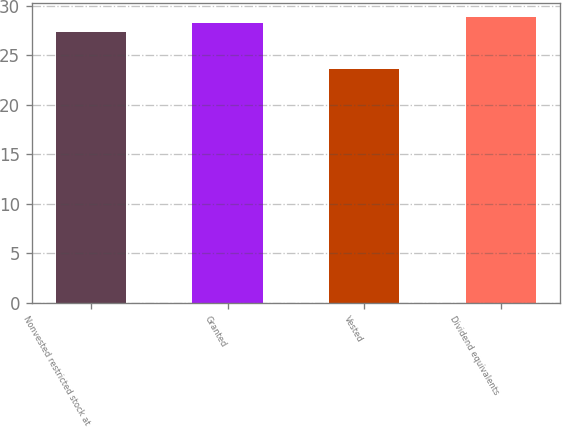<chart> <loc_0><loc_0><loc_500><loc_500><bar_chart><fcel>Nonvested restricted stock at<fcel>Granted<fcel>Vested<fcel>Dividend equivalents<nl><fcel>27.33<fcel>28.3<fcel>23.65<fcel>28.88<nl></chart> 